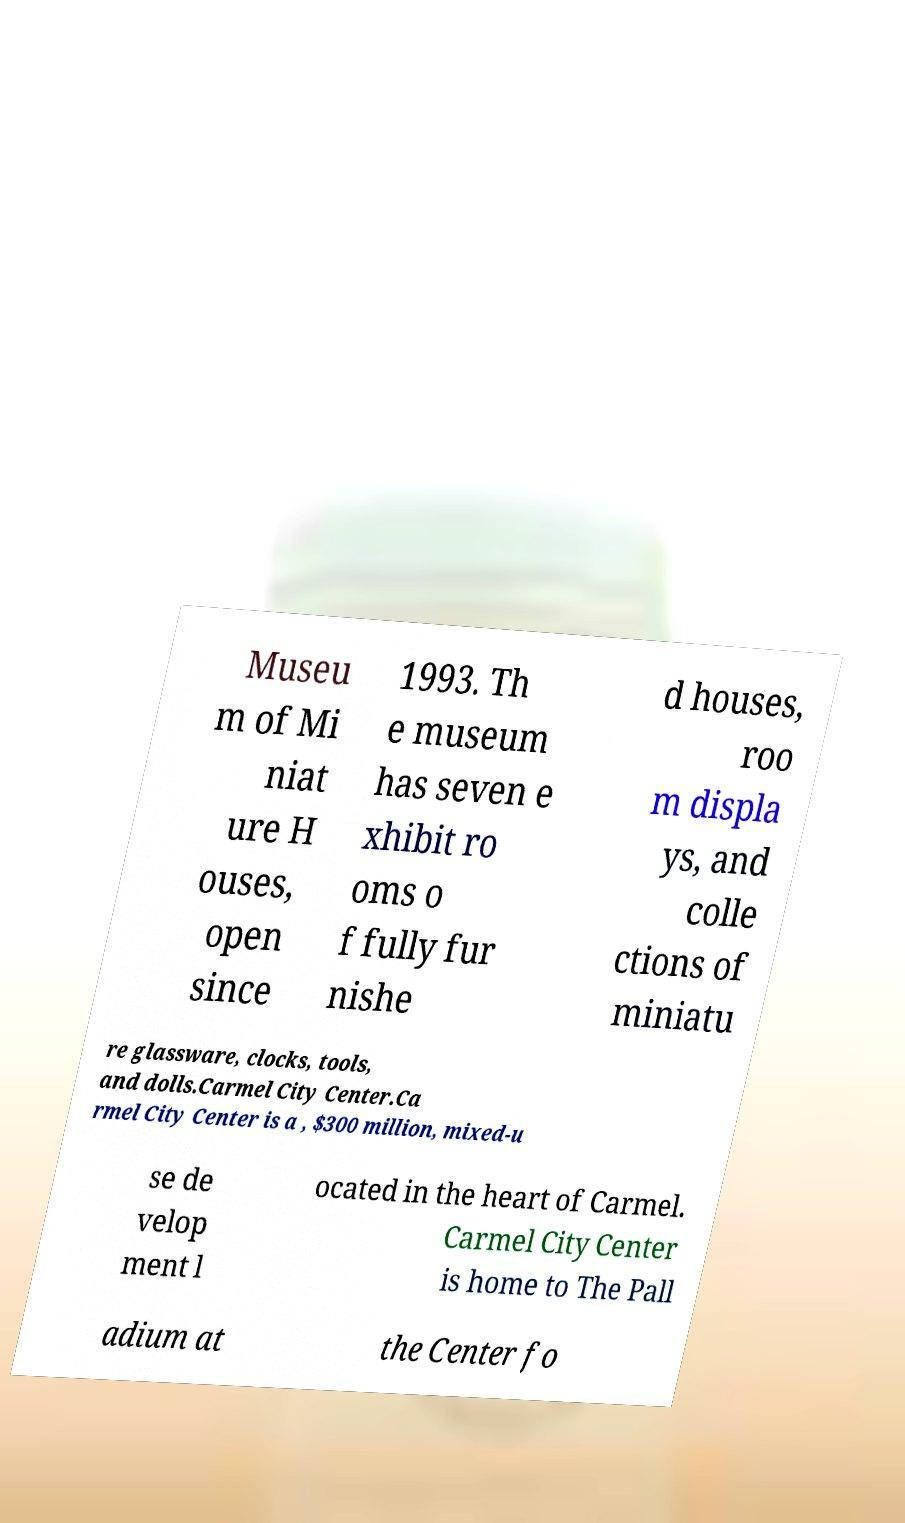Can you read and provide the text displayed in the image?This photo seems to have some interesting text. Can you extract and type it out for me? Museu m of Mi niat ure H ouses, open since 1993. Th e museum has seven e xhibit ro oms o f fully fur nishe d houses, roo m displa ys, and colle ctions of miniatu re glassware, clocks, tools, and dolls.Carmel City Center.Ca rmel City Center is a , $300 million, mixed-u se de velop ment l ocated in the heart of Carmel. Carmel City Center is home to The Pall adium at the Center fo 